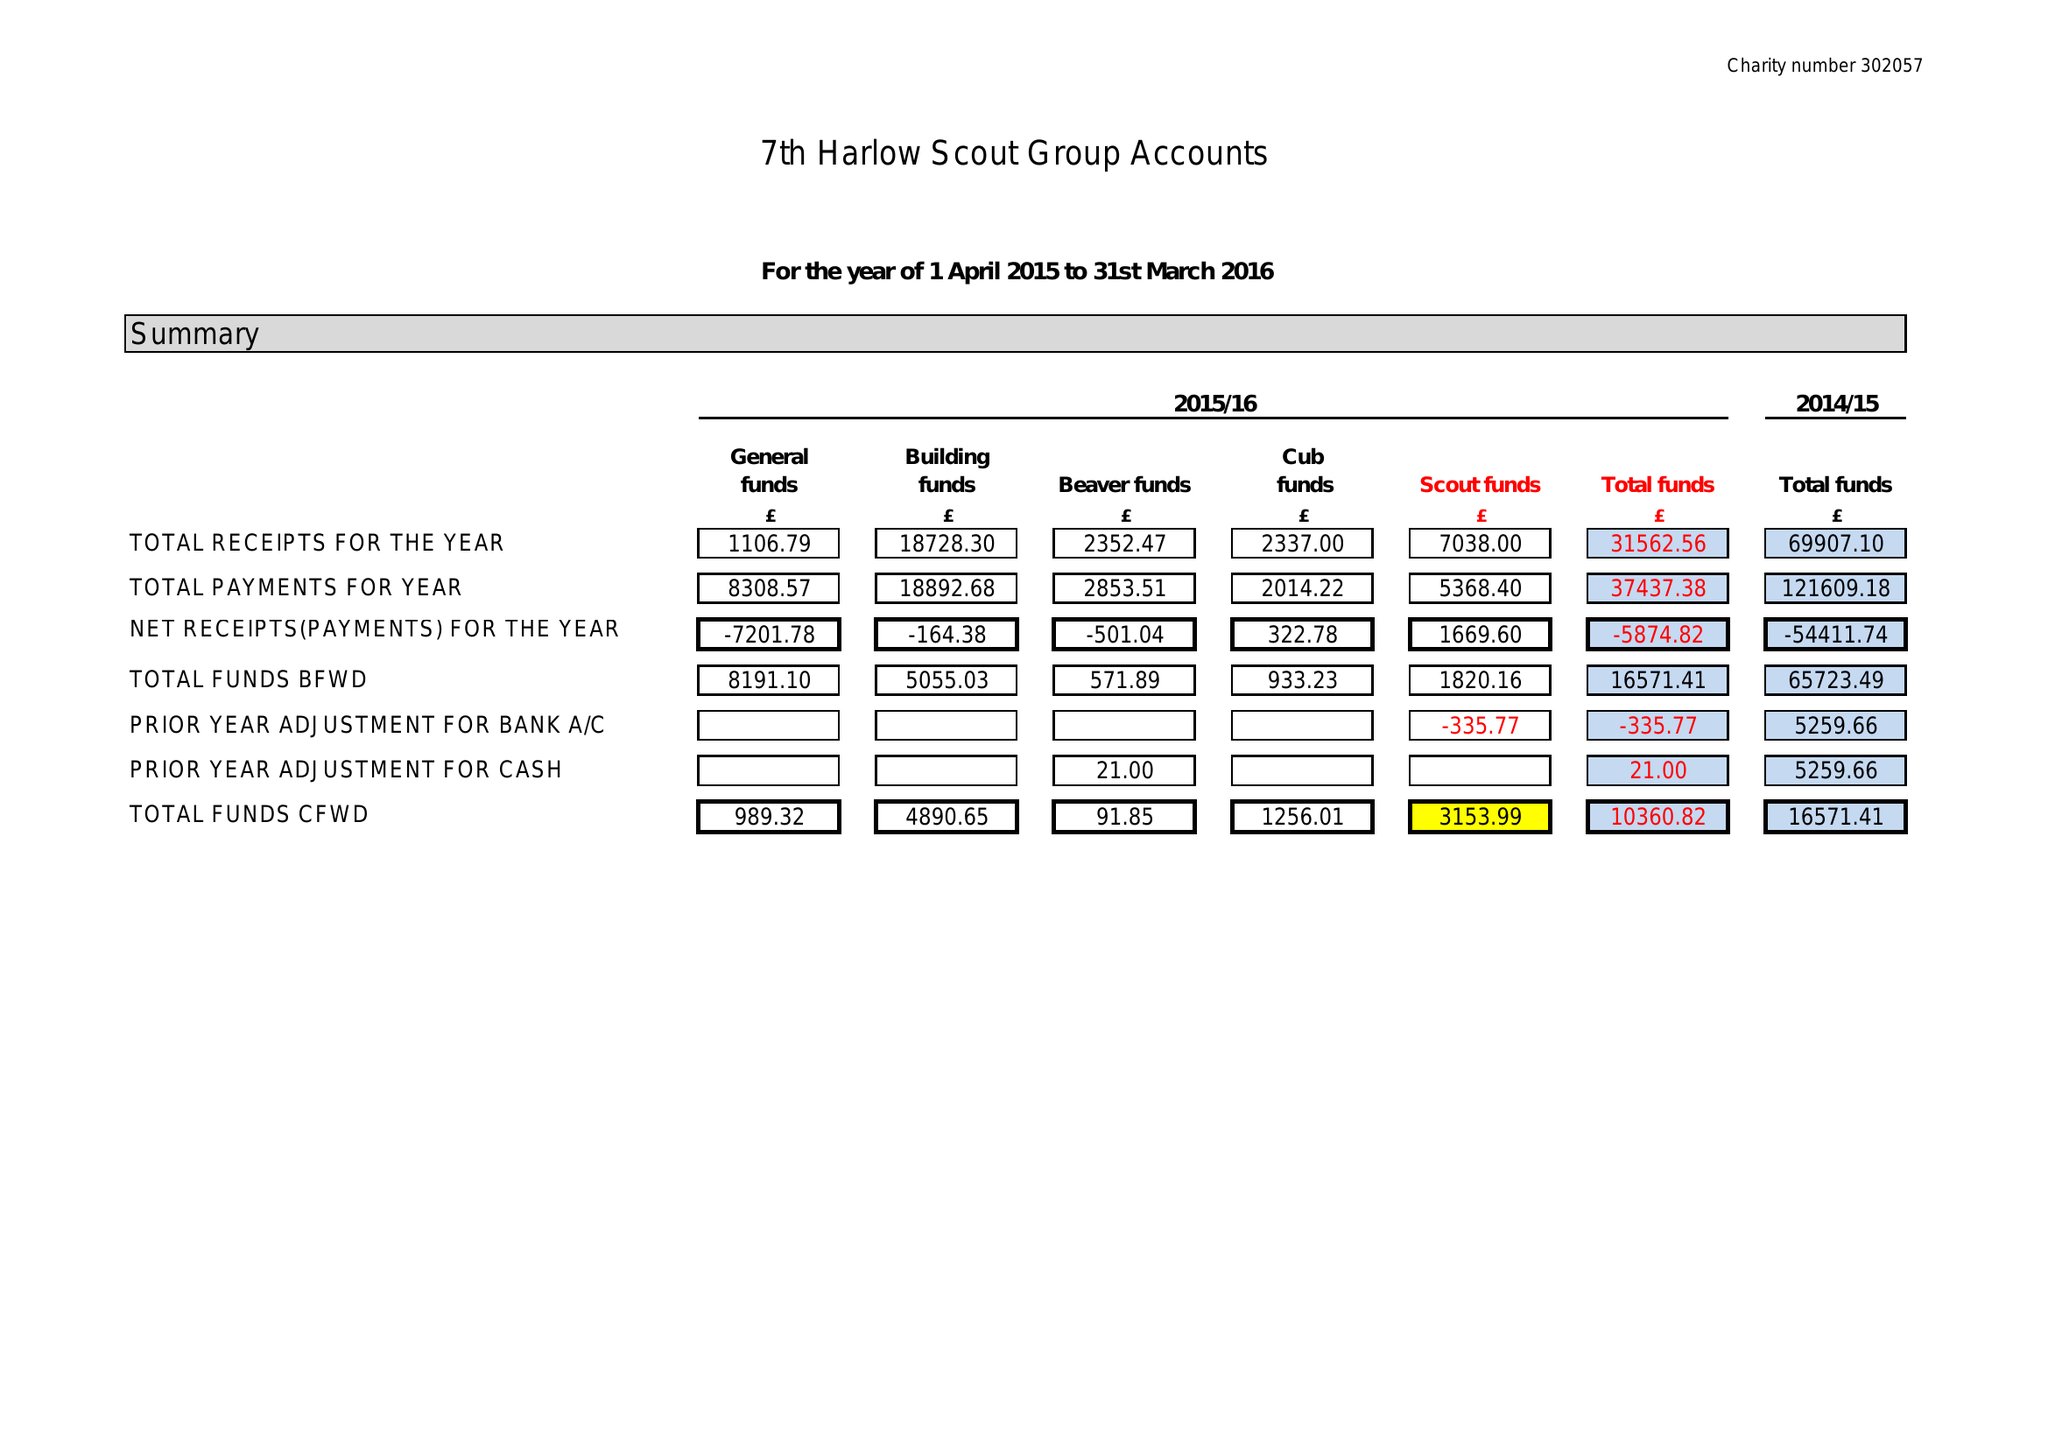What is the value for the spending_annually_in_british_pounds?
Answer the question using a single word or phrase. 37437.00 